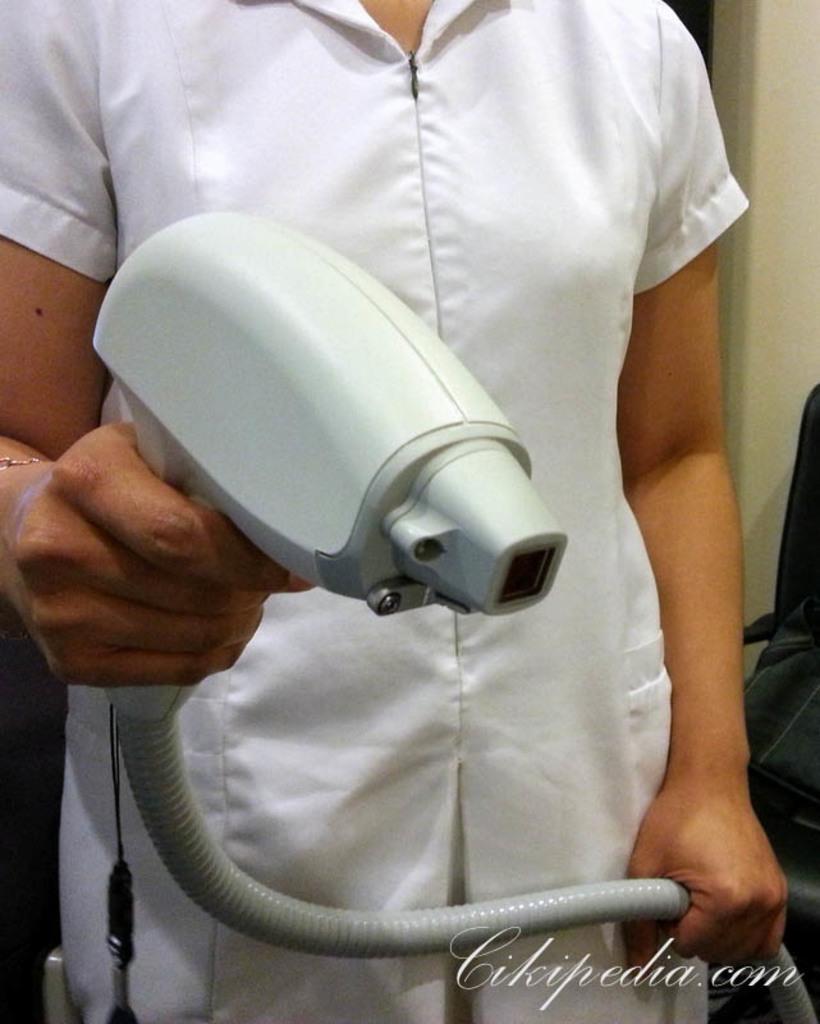Please provide a concise description of this image. In the picture I can see a person wearing a white color dress is holding a machine with a pipe in their hands. Here we can see a watermark at the bottom right side of the image. In the background, I can see a black color object. 